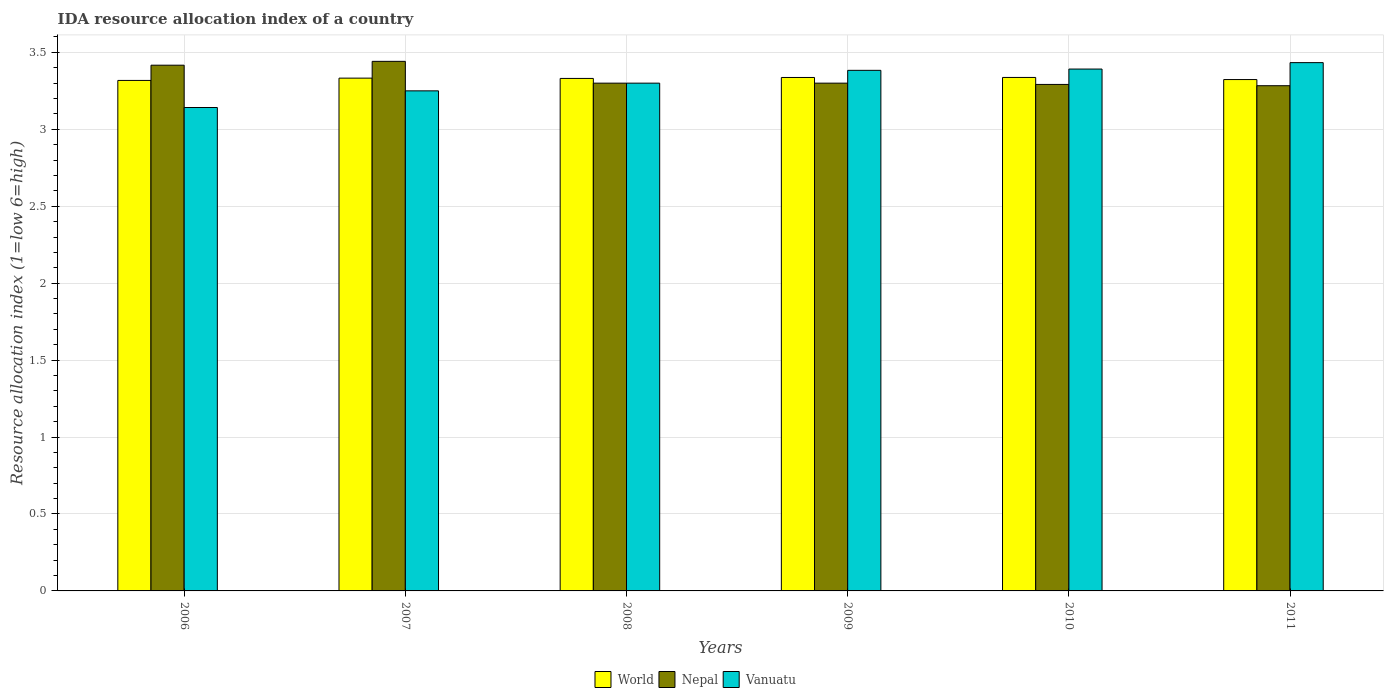Are the number of bars on each tick of the X-axis equal?
Provide a succinct answer. Yes. How many bars are there on the 6th tick from the left?
Your answer should be very brief. 3. What is the IDA resource allocation index in Vanuatu in 2006?
Offer a very short reply. 3.14. Across all years, what is the maximum IDA resource allocation index in Nepal?
Make the answer very short. 3.44. Across all years, what is the minimum IDA resource allocation index in Nepal?
Give a very brief answer. 3.28. What is the total IDA resource allocation index in World in the graph?
Ensure brevity in your answer.  19.98. What is the difference between the IDA resource allocation index in World in 2006 and that in 2007?
Offer a terse response. -0.01. What is the difference between the IDA resource allocation index in World in 2010 and the IDA resource allocation index in Vanuatu in 2009?
Provide a succinct answer. -0.05. What is the average IDA resource allocation index in World per year?
Offer a very short reply. 3.33. In the year 2006, what is the difference between the IDA resource allocation index in World and IDA resource allocation index in Nepal?
Offer a very short reply. -0.1. What is the ratio of the IDA resource allocation index in World in 2009 to that in 2011?
Offer a terse response. 1. Is the difference between the IDA resource allocation index in World in 2010 and 2011 greater than the difference between the IDA resource allocation index in Nepal in 2010 and 2011?
Offer a very short reply. Yes. What is the difference between the highest and the second highest IDA resource allocation index in World?
Keep it short and to the point. 0. What is the difference between the highest and the lowest IDA resource allocation index in Nepal?
Offer a very short reply. 0.16. In how many years, is the IDA resource allocation index in Nepal greater than the average IDA resource allocation index in Nepal taken over all years?
Provide a succinct answer. 2. Is the sum of the IDA resource allocation index in Nepal in 2006 and 2011 greater than the maximum IDA resource allocation index in Vanuatu across all years?
Keep it short and to the point. Yes. What does the 3rd bar from the left in 2011 represents?
Keep it short and to the point. Vanuatu. How many bars are there?
Your answer should be compact. 18. Are all the bars in the graph horizontal?
Your response must be concise. No. What is the difference between two consecutive major ticks on the Y-axis?
Give a very brief answer. 0.5. Does the graph contain any zero values?
Keep it short and to the point. No. Where does the legend appear in the graph?
Provide a succinct answer. Bottom center. How many legend labels are there?
Offer a terse response. 3. What is the title of the graph?
Your answer should be very brief. IDA resource allocation index of a country. Does "Syrian Arab Republic" appear as one of the legend labels in the graph?
Offer a terse response. No. What is the label or title of the Y-axis?
Make the answer very short. Resource allocation index (1=low 6=high). What is the Resource allocation index (1=low 6=high) in World in 2006?
Provide a short and direct response. 3.32. What is the Resource allocation index (1=low 6=high) of Nepal in 2006?
Make the answer very short. 3.42. What is the Resource allocation index (1=low 6=high) in Vanuatu in 2006?
Your answer should be compact. 3.14. What is the Resource allocation index (1=low 6=high) of World in 2007?
Your answer should be very brief. 3.33. What is the Resource allocation index (1=low 6=high) of Nepal in 2007?
Provide a short and direct response. 3.44. What is the Resource allocation index (1=low 6=high) of World in 2008?
Keep it short and to the point. 3.33. What is the Resource allocation index (1=low 6=high) of Nepal in 2008?
Ensure brevity in your answer.  3.3. What is the Resource allocation index (1=low 6=high) in World in 2009?
Provide a succinct answer. 3.34. What is the Resource allocation index (1=low 6=high) of Nepal in 2009?
Your response must be concise. 3.3. What is the Resource allocation index (1=low 6=high) of Vanuatu in 2009?
Offer a very short reply. 3.38. What is the Resource allocation index (1=low 6=high) in World in 2010?
Your response must be concise. 3.34. What is the Resource allocation index (1=low 6=high) of Nepal in 2010?
Your answer should be very brief. 3.29. What is the Resource allocation index (1=low 6=high) in Vanuatu in 2010?
Give a very brief answer. 3.39. What is the Resource allocation index (1=low 6=high) in World in 2011?
Make the answer very short. 3.32. What is the Resource allocation index (1=low 6=high) in Nepal in 2011?
Keep it short and to the point. 3.28. What is the Resource allocation index (1=low 6=high) of Vanuatu in 2011?
Make the answer very short. 3.43. Across all years, what is the maximum Resource allocation index (1=low 6=high) of World?
Your response must be concise. 3.34. Across all years, what is the maximum Resource allocation index (1=low 6=high) in Nepal?
Give a very brief answer. 3.44. Across all years, what is the maximum Resource allocation index (1=low 6=high) in Vanuatu?
Provide a short and direct response. 3.43. Across all years, what is the minimum Resource allocation index (1=low 6=high) of World?
Give a very brief answer. 3.32. Across all years, what is the minimum Resource allocation index (1=low 6=high) in Nepal?
Ensure brevity in your answer.  3.28. Across all years, what is the minimum Resource allocation index (1=low 6=high) of Vanuatu?
Offer a terse response. 3.14. What is the total Resource allocation index (1=low 6=high) in World in the graph?
Give a very brief answer. 19.98. What is the total Resource allocation index (1=low 6=high) of Nepal in the graph?
Make the answer very short. 20.03. What is the difference between the Resource allocation index (1=low 6=high) of World in 2006 and that in 2007?
Provide a short and direct response. -0.01. What is the difference between the Resource allocation index (1=low 6=high) of Nepal in 2006 and that in 2007?
Your answer should be compact. -0.03. What is the difference between the Resource allocation index (1=low 6=high) in Vanuatu in 2006 and that in 2007?
Provide a succinct answer. -0.11. What is the difference between the Resource allocation index (1=low 6=high) of World in 2006 and that in 2008?
Provide a short and direct response. -0.01. What is the difference between the Resource allocation index (1=low 6=high) of Nepal in 2006 and that in 2008?
Your answer should be very brief. 0.12. What is the difference between the Resource allocation index (1=low 6=high) of Vanuatu in 2006 and that in 2008?
Ensure brevity in your answer.  -0.16. What is the difference between the Resource allocation index (1=low 6=high) of World in 2006 and that in 2009?
Make the answer very short. -0.02. What is the difference between the Resource allocation index (1=low 6=high) in Nepal in 2006 and that in 2009?
Keep it short and to the point. 0.12. What is the difference between the Resource allocation index (1=low 6=high) in Vanuatu in 2006 and that in 2009?
Your answer should be very brief. -0.24. What is the difference between the Resource allocation index (1=low 6=high) of World in 2006 and that in 2010?
Offer a very short reply. -0.02. What is the difference between the Resource allocation index (1=low 6=high) in Nepal in 2006 and that in 2010?
Provide a succinct answer. 0.12. What is the difference between the Resource allocation index (1=low 6=high) in World in 2006 and that in 2011?
Provide a short and direct response. -0.01. What is the difference between the Resource allocation index (1=low 6=high) in Nepal in 2006 and that in 2011?
Provide a succinct answer. 0.13. What is the difference between the Resource allocation index (1=low 6=high) of Vanuatu in 2006 and that in 2011?
Offer a terse response. -0.29. What is the difference between the Resource allocation index (1=low 6=high) in World in 2007 and that in 2008?
Keep it short and to the point. 0. What is the difference between the Resource allocation index (1=low 6=high) of Nepal in 2007 and that in 2008?
Offer a very short reply. 0.14. What is the difference between the Resource allocation index (1=low 6=high) in Vanuatu in 2007 and that in 2008?
Provide a short and direct response. -0.05. What is the difference between the Resource allocation index (1=low 6=high) in World in 2007 and that in 2009?
Provide a succinct answer. -0. What is the difference between the Resource allocation index (1=low 6=high) of Nepal in 2007 and that in 2009?
Provide a succinct answer. 0.14. What is the difference between the Resource allocation index (1=low 6=high) in Vanuatu in 2007 and that in 2009?
Offer a terse response. -0.13. What is the difference between the Resource allocation index (1=low 6=high) of World in 2007 and that in 2010?
Your answer should be compact. -0. What is the difference between the Resource allocation index (1=low 6=high) of Vanuatu in 2007 and that in 2010?
Your response must be concise. -0.14. What is the difference between the Resource allocation index (1=low 6=high) in World in 2007 and that in 2011?
Provide a succinct answer. 0.01. What is the difference between the Resource allocation index (1=low 6=high) in Nepal in 2007 and that in 2011?
Offer a terse response. 0.16. What is the difference between the Resource allocation index (1=low 6=high) of Vanuatu in 2007 and that in 2011?
Your answer should be very brief. -0.18. What is the difference between the Resource allocation index (1=low 6=high) of World in 2008 and that in 2009?
Give a very brief answer. -0.01. What is the difference between the Resource allocation index (1=low 6=high) of Nepal in 2008 and that in 2009?
Your answer should be compact. 0. What is the difference between the Resource allocation index (1=low 6=high) of Vanuatu in 2008 and that in 2009?
Keep it short and to the point. -0.08. What is the difference between the Resource allocation index (1=low 6=high) of World in 2008 and that in 2010?
Offer a terse response. -0.01. What is the difference between the Resource allocation index (1=low 6=high) in Nepal in 2008 and that in 2010?
Provide a succinct answer. 0.01. What is the difference between the Resource allocation index (1=low 6=high) of Vanuatu in 2008 and that in 2010?
Keep it short and to the point. -0.09. What is the difference between the Resource allocation index (1=low 6=high) in World in 2008 and that in 2011?
Your response must be concise. 0.01. What is the difference between the Resource allocation index (1=low 6=high) in Nepal in 2008 and that in 2011?
Make the answer very short. 0.02. What is the difference between the Resource allocation index (1=low 6=high) of Vanuatu in 2008 and that in 2011?
Give a very brief answer. -0.13. What is the difference between the Resource allocation index (1=low 6=high) in World in 2009 and that in 2010?
Make the answer very short. -0. What is the difference between the Resource allocation index (1=low 6=high) of Nepal in 2009 and that in 2010?
Your response must be concise. 0.01. What is the difference between the Resource allocation index (1=low 6=high) of Vanuatu in 2009 and that in 2010?
Your answer should be very brief. -0.01. What is the difference between the Resource allocation index (1=low 6=high) of World in 2009 and that in 2011?
Offer a very short reply. 0.01. What is the difference between the Resource allocation index (1=low 6=high) in Nepal in 2009 and that in 2011?
Ensure brevity in your answer.  0.02. What is the difference between the Resource allocation index (1=low 6=high) in Vanuatu in 2009 and that in 2011?
Provide a succinct answer. -0.05. What is the difference between the Resource allocation index (1=low 6=high) in World in 2010 and that in 2011?
Your response must be concise. 0.01. What is the difference between the Resource allocation index (1=low 6=high) of Nepal in 2010 and that in 2011?
Provide a succinct answer. 0.01. What is the difference between the Resource allocation index (1=low 6=high) in Vanuatu in 2010 and that in 2011?
Your response must be concise. -0.04. What is the difference between the Resource allocation index (1=low 6=high) in World in 2006 and the Resource allocation index (1=low 6=high) in Nepal in 2007?
Your answer should be compact. -0.12. What is the difference between the Resource allocation index (1=low 6=high) in World in 2006 and the Resource allocation index (1=low 6=high) in Vanuatu in 2007?
Offer a very short reply. 0.07. What is the difference between the Resource allocation index (1=low 6=high) in Nepal in 2006 and the Resource allocation index (1=low 6=high) in Vanuatu in 2007?
Give a very brief answer. 0.17. What is the difference between the Resource allocation index (1=low 6=high) in World in 2006 and the Resource allocation index (1=low 6=high) in Nepal in 2008?
Ensure brevity in your answer.  0.02. What is the difference between the Resource allocation index (1=low 6=high) in World in 2006 and the Resource allocation index (1=low 6=high) in Vanuatu in 2008?
Your response must be concise. 0.02. What is the difference between the Resource allocation index (1=low 6=high) of Nepal in 2006 and the Resource allocation index (1=low 6=high) of Vanuatu in 2008?
Your answer should be compact. 0.12. What is the difference between the Resource allocation index (1=low 6=high) in World in 2006 and the Resource allocation index (1=low 6=high) in Nepal in 2009?
Offer a terse response. 0.02. What is the difference between the Resource allocation index (1=low 6=high) of World in 2006 and the Resource allocation index (1=low 6=high) of Vanuatu in 2009?
Your response must be concise. -0.07. What is the difference between the Resource allocation index (1=low 6=high) in Nepal in 2006 and the Resource allocation index (1=low 6=high) in Vanuatu in 2009?
Provide a succinct answer. 0.03. What is the difference between the Resource allocation index (1=low 6=high) of World in 2006 and the Resource allocation index (1=low 6=high) of Nepal in 2010?
Keep it short and to the point. 0.03. What is the difference between the Resource allocation index (1=low 6=high) in World in 2006 and the Resource allocation index (1=low 6=high) in Vanuatu in 2010?
Give a very brief answer. -0.07. What is the difference between the Resource allocation index (1=low 6=high) in Nepal in 2006 and the Resource allocation index (1=low 6=high) in Vanuatu in 2010?
Your answer should be compact. 0.03. What is the difference between the Resource allocation index (1=low 6=high) in World in 2006 and the Resource allocation index (1=low 6=high) in Nepal in 2011?
Ensure brevity in your answer.  0.03. What is the difference between the Resource allocation index (1=low 6=high) of World in 2006 and the Resource allocation index (1=low 6=high) of Vanuatu in 2011?
Keep it short and to the point. -0.12. What is the difference between the Resource allocation index (1=low 6=high) of Nepal in 2006 and the Resource allocation index (1=low 6=high) of Vanuatu in 2011?
Offer a terse response. -0.02. What is the difference between the Resource allocation index (1=low 6=high) in World in 2007 and the Resource allocation index (1=low 6=high) in Nepal in 2008?
Your answer should be compact. 0.03. What is the difference between the Resource allocation index (1=low 6=high) of World in 2007 and the Resource allocation index (1=low 6=high) of Vanuatu in 2008?
Ensure brevity in your answer.  0.03. What is the difference between the Resource allocation index (1=low 6=high) in Nepal in 2007 and the Resource allocation index (1=low 6=high) in Vanuatu in 2008?
Provide a short and direct response. 0.14. What is the difference between the Resource allocation index (1=low 6=high) in World in 2007 and the Resource allocation index (1=low 6=high) in Nepal in 2009?
Make the answer very short. 0.03. What is the difference between the Resource allocation index (1=low 6=high) in World in 2007 and the Resource allocation index (1=low 6=high) in Vanuatu in 2009?
Make the answer very short. -0.05. What is the difference between the Resource allocation index (1=low 6=high) in Nepal in 2007 and the Resource allocation index (1=low 6=high) in Vanuatu in 2009?
Your response must be concise. 0.06. What is the difference between the Resource allocation index (1=low 6=high) of World in 2007 and the Resource allocation index (1=low 6=high) of Nepal in 2010?
Your response must be concise. 0.04. What is the difference between the Resource allocation index (1=low 6=high) in World in 2007 and the Resource allocation index (1=low 6=high) in Vanuatu in 2010?
Your answer should be very brief. -0.06. What is the difference between the Resource allocation index (1=low 6=high) in World in 2007 and the Resource allocation index (1=low 6=high) in Nepal in 2011?
Make the answer very short. 0.05. What is the difference between the Resource allocation index (1=low 6=high) of World in 2007 and the Resource allocation index (1=low 6=high) of Vanuatu in 2011?
Provide a succinct answer. -0.1. What is the difference between the Resource allocation index (1=low 6=high) in Nepal in 2007 and the Resource allocation index (1=low 6=high) in Vanuatu in 2011?
Your answer should be compact. 0.01. What is the difference between the Resource allocation index (1=low 6=high) of World in 2008 and the Resource allocation index (1=low 6=high) of Nepal in 2009?
Keep it short and to the point. 0.03. What is the difference between the Resource allocation index (1=low 6=high) in World in 2008 and the Resource allocation index (1=low 6=high) in Vanuatu in 2009?
Keep it short and to the point. -0.05. What is the difference between the Resource allocation index (1=low 6=high) in Nepal in 2008 and the Resource allocation index (1=low 6=high) in Vanuatu in 2009?
Ensure brevity in your answer.  -0.08. What is the difference between the Resource allocation index (1=low 6=high) of World in 2008 and the Resource allocation index (1=low 6=high) of Nepal in 2010?
Keep it short and to the point. 0.04. What is the difference between the Resource allocation index (1=low 6=high) in World in 2008 and the Resource allocation index (1=low 6=high) in Vanuatu in 2010?
Provide a succinct answer. -0.06. What is the difference between the Resource allocation index (1=low 6=high) of Nepal in 2008 and the Resource allocation index (1=low 6=high) of Vanuatu in 2010?
Offer a very short reply. -0.09. What is the difference between the Resource allocation index (1=low 6=high) in World in 2008 and the Resource allocation index (1=low 6=high) in Nepal in 2011?
Provide a succinct answer. 0.05. What is the difference between the Resource allocation index (1=low 6=high) in World in 2008 and the Resource allocation index (1=low 6=high) in Vanuatu in 2011?
Your answer should be very brief. -0.1. What is the difference between the Resource allocation index (1=low 6=high) of Nepal in 2008 and the Resource allocation index (1=low 6=high) of Vanuatu in 2011?
Ensure brevity in your answer.  -0.13. What is the difference between the Resource allocation index (1=low 6=high) of World in 2009 and the Resource allocation index (1=low 6=high) of Nepal in 2010?
Make the answer very short. 0.05. What is the difference between the Resource allocation index (1=low 6=high) of World in 2009 and the Resource allocation index (1=low 6=high) of Vanuatu in 2010?
Keep it short and to the point. -0.05. What is the difference between the Resource allocation index (1=low 6=high) of Nepal in 2009 and the Resource allocation index (1=low 6=high) of Vanuatu in 2010?
Give a very brief answer. -0.09. What is the difference between the Resource allocation index (1=low 6=high) of World in 2009 and the Resource allocation index (1=low 6=high) of Nepal in 2011?
Make the answer very short. 0.05. What is the difference between the Resource allocation index (1=low 6=high) of World in 2009 and the Resource allocation index (1=low 6=high) of Vanuatu in 2011?
Provide a succinct answer. -0.1. What is the difference between the Resource allocation index (1=low 6=high) of Nepal in 2009 and the Resource allocation index (1=low 6=high) of Vanuatu in 2011?
Provide a succinct answer. -0.13. What is the difference between the Resource allocation index (1=low 6=high) in World in 2010 and the Resource allocation index (1=low 6=high) in Nepal in 2011?
Offer a terse response. 0.05. What is the difference between the Resource allocation index (1=low 6=high) of World in 2010 and the Resource allocation index (1=low 6=high) of Vanuatu in 2011?
Offer a terse response. -0.1. What is the difference between the Resource allocation index (1=low 6=high) in Nepal in 2010 and the Resource allocation index (1=low 6=high) in Vanuatu in 2011?
Keep it short and to the point. -0.14. What is the average Resource allocation index (1=low 6=high) of World per year?
Offer a very short reply. 3.33. What is the average Resource allocation index (1=low 6=high) in Nepal per year?
Offer a very short reply. 3.34. What is the average Resource allocation index (1=low 6=high) of Vanuatu per year?
Keep it short and to the point. 3.32. In the year 2006, what is the difference between the Resource allocation index (1=low 6=high) of World and Resource allocation index (1=low 6=high) of Nepal?
Keep it short and to the point. -0.1. In the year 2006, what is the difference between the Resource allocation index (1=low 6=high) of World and Resource allocation index (1=low 6=high) of Vanuatu?
Make the answer very short. 0.18. In the year 2006, what is the difference between the Resource allocation index (1=low 6=high) of Nepal and Resource allocation index (1=low 6=high) of Vanuatu?
Your answer should be very brief. 0.28. In the year 2007, what is the difference between the Resource allocation index (1=low 6=high) of World and Resource allocation index (1=low 6=high) of Nepal?
Provide a succinct answer. -0.11. In the year 2007, what is the difference between the Resource allocation index (1=low 6=high) of World and Resource allocation index (1=low 6=high) of Vanuatu?
Your answer should be very brief. 0.08. In the year 2007, what is the difference between the Resource allocation index (1=low 6=high) of Nepal and Resource allocation index (1=low 6=high) of Vanuatu?
Offer a terse response. 0.19. In the year 2008, what is the difference between the Resource allocation index (1=low 6=high) of World and Resource allocation index (1=low 6=high) of Nepal?
Keep it short and to the point. 0.03. In the year 2008, what is the difference between the Resource allocation index (1=low 6=high) in World and Resource allocation index (1=low 6=high) in Vanuatu?
Provide a short and direct response. 0.03. In the year 2009, what is the difference between the Resource allocation index (1=low 6=high) of World and Resource allocation index (1=low 6=high) of Nepal?
Provide a short and direct response. 0.04. In the year 2009, what is the difference between the Resource allocation index (1=low 6=high) in World and Resource allocation index (1=low 6=high) in Vanuatu?
Ensure brevity in your answer.  -0.05. In the year 2009, what is the difference between the Resource allocation index (1=low 6=high) of Nepal and Resource allocation index (1=low 6=high) of Vanuatu?
Give a very brief answer. -0.08. In the year 2010, what is the difference between the Resource allocation index (1=low 6=high) of World and Resource allocation index (1=low 6=high) of Nepal?
Your answer should be compact. 0.05. In the year 2010, what is the difference between the Resource allocation index (1=low 6=high) in World and Resource allocation index (1=low 6=high) in Vanuatu?
Provide a short and direct response. -0.05. In the year 2011, what is the difference between the Resource allocation index (1=low 6=high) in World and Resource allocation index (1=low 6=high) in Nepal?
Keep it short and to the point. 0.04. In the year 2011, what is the difference between the Resource allocation index (1=low 6=high) of World and Resource allocation index (1=low 6=high) of Vanuatu?
Offer a terse response. -0.11. What is the ratio of the Resource allocation index (1=low 6=high) in Vanuatu in 2006 to that in 2007?
Ensure brevity in your answer.  0.97. What is the ratio of the Resource allocation index (1=low 6=high) of World in 2006 to that in 2008?
Keep it short and to the point. 1. What is the ratio of the Resource allocation index (1=low 6=high) in Nepal in 2006 to that in 2008?
Your answer should be compact. 1.04. What is the ratio of the Resource allocation index (1=low 6=high) of World in 2006 to that in 2009?
Your response must be concise. 0.99. What is the ratio of the Resource allocation index (1=low 6=high) in Nepal in 2006 to that in 2009?
Your answer should be very brief. 1.04. What is the ratio of the Resource allocation index (1=low 6=high) in Vanuatu in 2006 to that in 2009?
Ensure brevity in your answer.  0.93. What is the ratio of the Resource allocation index (1=low 6=high) of World in 2006 to that in 2010?
Ensure brevity in your answer.  0.99. What is the ratio of the Resource allocation index (1=low 6=high) of Nepal in 2006 to that in 2010?
Give a very brief answer. 1.04. What is the ratio of the Resource allocation index (1=low 6=high) of Vanuatu in 2006 to that in 2010?
Your answer should be very brief. 0.93. What is the ratio of the Resource allocation index (1=low 6=high) in Nepal in 2006 to that in 2011?
Offer a terse response. 1.04. What is the ratio of the Resource allocation index (1=low 6=high) of Vanuatu in 2006 to that in 2011?
Offer a very short reply. 0.92. What is the ratio of the Resource allocation index (1=low 6=high) of Nepal in 2007 to that in 2008?
Provide a succinct answer. 1.04. What is the ratio of the Resource allocation index (1=low 6=high) of Vanuatu in 2007 to that in 2008?
Provide a short and direct response. 0.98. What is the ratio of the Resource allocation index (1=low 6=high) in Nepal in 2007 to that in 2009?
Your response must be concise. 1.04. What is the ratio of the Resource allocation index (1=low 6=high) of Vanuatu in 2007 to that in 2009?
Provide a short and direct response. 0.96. What is the ratio of the Resource allocation index (1=low 6=high) in Nepal in 2007 to that in 2010?
Offer a very short reply. 1.05. What is the ratio of the Resource allocation index (1=low 6=high) of Vanuatu in 2007 to that in 2010?
Offer a terse response. 0.96. What is the ratio of the Resource allocation index (1=low 6=high) of Nepal in 2007 to that in 2011?
Offer a very short reply. 1.05. What is the ratio of the Resource allocation index (1=low 6=high) of Vanuatu in 2007 to that in 2011?
Ensure brevity in your answer.  0.95. What is the ratio of the Resource allocation index (1=low 6=high) in World in 2008 to that in 2009?
Provide a short and direct response. 1. What is the ratio of the Resource allocation index (1=low 6=high) in Vanuatu in 2008 to that in 2009?
Your response must be concise. 0.98. What is the ratio of the Resource allocation index (1=low 6=high) in World in 2008 to that in 2011?
Give a very brief answer. 1. What is the ratio of the Resource allocation index (1=low 6=high) in Vanuatu in 2008 to that in 2011?
Ensure brevity in your answer.  0.96. What is the ratio of the Resource allocation index (1=low 6=high) of Nepal in 2009 to that in 2010?
Your answer should be very brief. 1. What is the ratio of the Resource allocation index (1=low 6=high) of World in 2009 to that in 2011?
Ensure brevity in your answer.  1. What is the ratio of the Resource allocation index (1=low 6=high) in Nepal in 2009 to that in 2011?
Offer a very short reply. 1.01. What is the ratio of the Resource allocation index (1=low 6=high) in Vanuatu in 2009 to that in 2011?
Provide a short and direct response. 0.99. What is the ratio of the Resource allocation index (1=low 6=high) in World in 2010 to that in 2011?
Offer a very short reply. 1. What is the ratio of the Resource allocation index (1=low 6=high) of Vanuatu in 2010 to that in 2011?
Keep it short and to the point. 0.99. What is the difference between the highest and the second highest Resource allocation index (1=low 6=high) of World?
Make the answer very short. 0. What is the difference between the highest and the second highest Resource allocation index (1=low 6=high) in Nepal?
Your answer should be compact. 0.03. What is the difference between the highest and the second highest Resource allocation index (1=low 6=high) in Vanuatu?
Offer a terse response. 0.04. What is the difference between the highest and the lowest Resource allocation index (1=low 6=high) of World?
Provide a succinct answer. 0.02. What is the difference between the highest and the lowest Resource allocation index (1=low 6=high) in Nepal?
Provide a short and direct response. 0.16. What is the difference between the highest and the lowest Resource allocation index (1=low 6=high) in Vanuatu?
Offer a terse response. 0.29. 